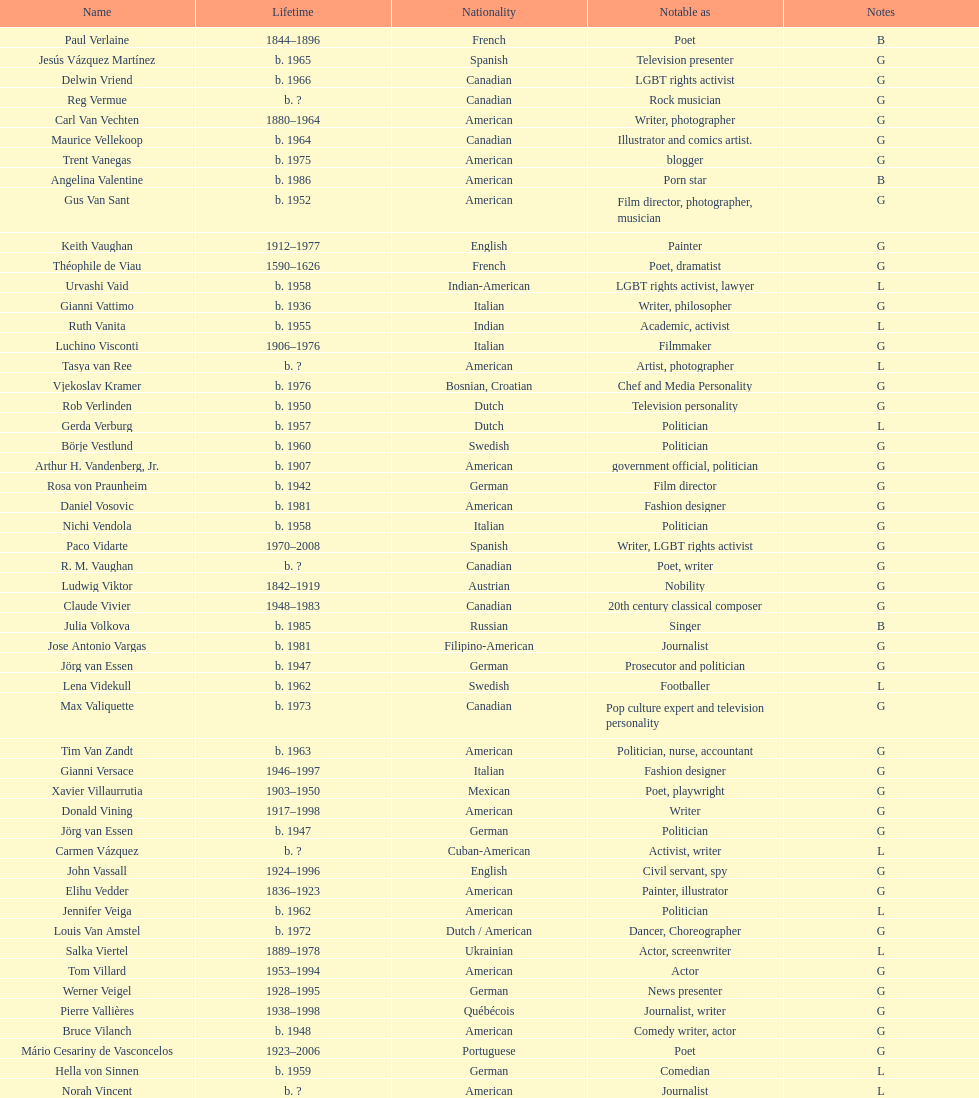Who lived longer, van vechten or variacoes? Van Vechten. 